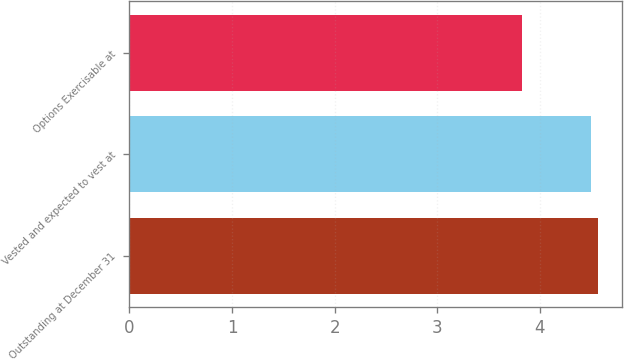<chart> <loc_0><loc_0><loc_500><loc_500><bar_chart><fcel>Outstanding at December 31<fcel>Vested and expected to vest at<fcel>Options Exercisable at<nl><fcel>4.57<fcel>4.5<fcel>3.83<nl></chart> 